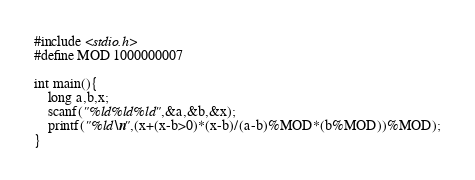<code> <loc_0><loc_0><loc_500><loc_500><_C_>#include <stdio.h>
#define MOD 1000000007

int main(){
	long a,b,x;
	scanf("%ld%ld%ld",&a,&b,&x);
	printf("%ld\n",(x+(x-b>0)*(x-b)/(a-b)%MOD*(b%MOD))%MOD);
}
</code> 